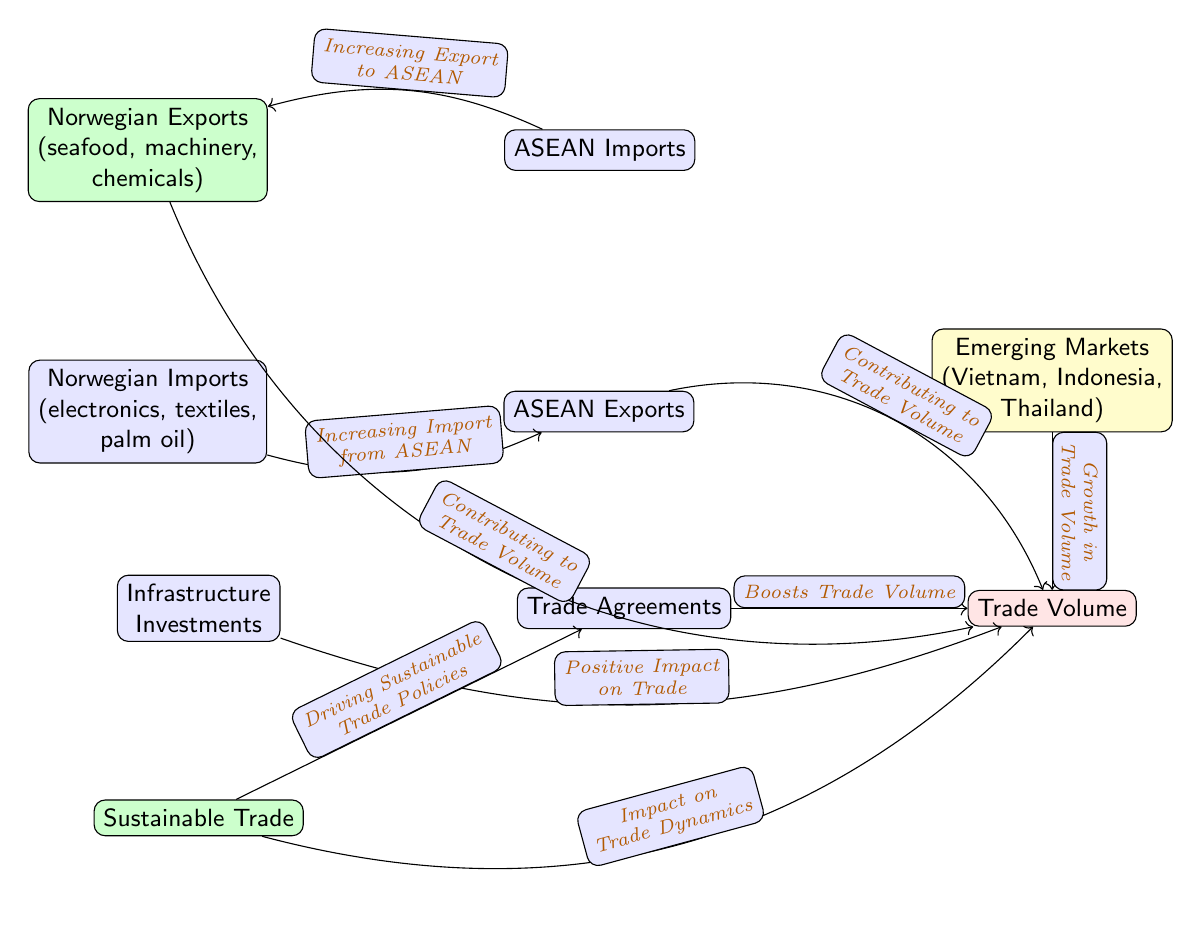What are the main Norwegian exports to ASEAN countries? The diagram lists "seafood, machinery, chemicals" as the primary exports from Norway to ASEAN countries. These categories are shown in the node labeled “Norwegian Exports.”
Answer: seafood, machinery, chemicals Which emerging markets are highlighted in the diagram? The diagram mentions "Vietnam, Indonesia, Thailand" as the emerging markets related to trade supply and demand dynamics in the context of ASEAN relations. These are detailed in the node labeled “Emerging Markets.”
Answer: Vietnam, Indonesia, Thailand How does increasing imports from ASEAN affect trade volume? The diagram indicates that there is a connection between "Increasing Import from ASEAN" and "Trade Volume." This relationship shows how imports can contribute to the overall trade dynamics and volume in the region.
Answer: Contributing to Trade Volume What impact do trade agreements have on trade volume? The relationship from "Trade Agreements" to "Trade Volume" in the diagram shows that trade agreements are a significant factor in boosting the trade volume between Norway and ASEAN countries.
Answer: Boosts Trade Volume How many main nodes are in the diagram? The diagram contains eight main nodes that represent various aspects of the trade relationship between Norway and ASEAN. Each node depicts different elements, such as exports, imports, and trade agreements.
Answer: 8 What is the role of infrastructure investments in trade dynamics? According to the diagram, "Infrastructure Investments" positively impact trade, indicated by the flow from this node to "Trade Volume." This shows that infrastructure supports and enhances trade relations.
Answer: Positive Impact on Trade What does sustainable trade aim to drive according to the diagram? The node labeled “Sustainable Trade” implies that it is pivotal in driving "Sustainable Trade Policies," highlighting its role in shaping a responsible and environmentally friendly trade framework.
Answer: Driving Sustainable Trade Policies What relationship exists between Norwegian exports and ASEAN imports? The diagram illustrates a bi-directional relationship where "Increasing Export to ASEAN" from Norwegian sources impacts ASEAN imports, indicating a flow of goods that benefits both sides.
Answer: Increasing Export to ASEAN What types of goods does Norway import from ASEAN countries? The diagram specifies "electronics, textiles, palm oil" as the primary imports from ASEAN into Norway, outlining the goods that Norway seeks from ASEAN markets for its supply needs.
Answer: electronics, textiles, palm oil 